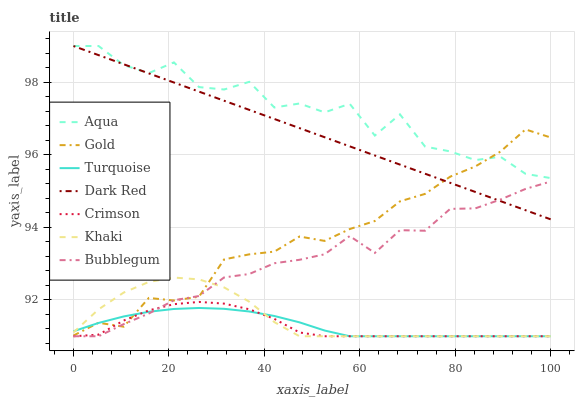Does Crimson have the minimum area under the curve?
Answer yes or no. Yes. Does Aqua have the maximum area under the curve?
Answer yes or no. Yes. Does Khaki have the minimum area under the curve?
Answer yes or no. No. Does Khaki have the maximum area under the curve?
Answer yes or no. No. Is Dark Red the smoothest?
Answer yes or no. Yes. Is Aqua the roughest?
Answer yes or no. Yes. Is Khaki the smoothest?
Answer yes or no. No. Is Khaki the roughest?
Answer yes or no. No. Does Turquoise have the lowest value?
Answer yes or no. Yes. Does Gold have the lowest value?
Answer yes or no. No. Does Aqua have the highest value?
Answer yes or no. Yes. Does Khaki have the highest value?
Answer yes or no. No. Is Khaki less than Dark Red?
Answer yes or no. Yes. Is Dark Red greater than Turquoise?
Answer yes or no. Yes. Does Aqua intersect Dark Red?
Answer yes or no. Yes. Is Aqua less than Dark Red?
Answer yes or no. No. Is Aqua greater than Dark Red?
Answer yes or no. No. Does Khaki intersect Dark Red?
Answer yes or no. No. 